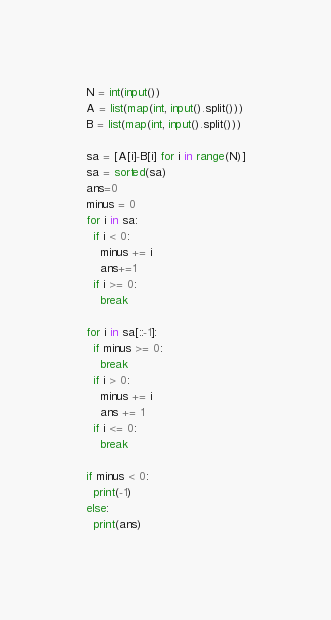<code> <loc_0><loc_0><loc_500><loc_500><_Python_>N = int(input())
A = list(map(int, input().split()))
B = list(map(int, input().split()))

sa = [A[i]-B[i] for i in range(N)]
sa = sorted(sa)
ans=0
minus = 0
for i in sa:
  if i < 0:
    minus += i
    ans+=1
  if i >= 0:
    break

for i in sa[::-1]:
  if minus >= 0:
    break
  if i > 0:
    minus += i
    ans += 1
  if i <= 0:
    break
    
if minus < 0:
  print(-1)
else:
  print(ans)</code> 